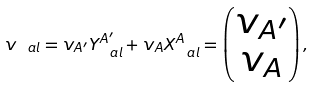Convert formula to latex. <formula><loc_0><loc_0><loc_500><loc_500>v _ { \ a l } = v _ { A ^ { \prime } } Y ^ { A ^ { \prime } } _ { \ a l } + v _ { A } X ^ { A } _ { \ a l } = \begin{pmatrix} v _ { A ^ { \prime } } \\ v _ { A } \end{pmatrix} ,</formula> 